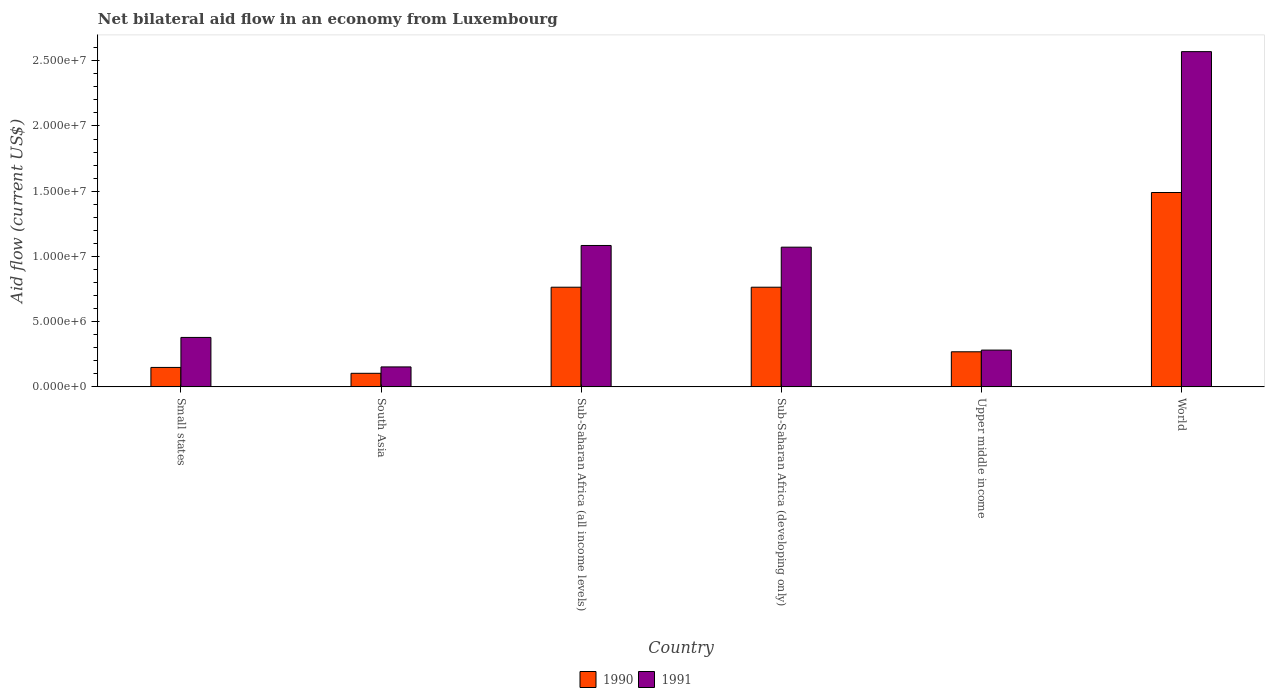Are the number of bars per tick equal to the number of legend labels?
Ensure brevity in your answer.  Yes. How many bars are there on the 3rd tick from the left?
Make the answer very short. 2. What is the label of the 4th group of bars from the left?
Make the answer very short. Sub-Saharan Africa (developing only). What is the net bilateral aid flow in 1991 in Upper middle income?
Give a very brief answer. 2.82e+06. Across all countries, what is the maximum net bilateral aid flow in 1991?
Your answer should be very brief. 2.57e+07. Across all countries, what is the minimum net bilateral aid flow in 1990?
Make the answer very short. 1.04e+06. In which country was the net bilateral aid flow in 1991 minimum?
Ensure brevity in your answer.  South Asia. What is the total net bilateral aid flow in 1990 in the graph?
Provide a short and direct response. 3.54e+07. What is the difference between the net bilateral aid flow in 1991 in Small states and that in World?
Provide a short and direct response. -2.19e+07. What is the difference between the net bilateral aid flow in 1991 in Small states and the net bilateral aid flow in 1990 in World?
Your answer should be compact. -1.11e+07. What is the average net bilateral aid flow in 1990 per country?
Keep it short and to the point. 5.90e+06. What is the difference between the net bilateral aid flow of/in 1991 and net bilateral aid flow of/in 1990 in World?
Your response must be concise. 1.08e+07. In how many countries, is the net bilateral aid flow in 1991 greater than 13000000 US$?
Your answer should be compact. 1. What is the ratio of the net bilateral aid flow in 1991 in Small states to that in World?
Make the answer very short. 0.15. Is the difference between the net bilateral aid flow in 1991 in South Asia and Upper middle income greater than the difference between the net bilateral aid flow in 1990 in South Asia and Upper middle income?
Keep it short and to the point. Yes. What is the difference between the highest and the second highest net bilateral aid flow in 1991?
Give a very brief answer. 1.50e+07. What is the difference between the highest and the lowest net bilateral aid flow in 1990?
Provide a succinct answer. 1.39e+07. What does the 2nd bar from the left in Sub-Saharan Africa (all income levels) represents?
Offer a terse response. 1991. What does the 2nd bar from the right in Sub-Saharan Africa (all income levels) represents?
Keep it short and to the point. 1990. How many bars are there?
Keep it short and to the point. 12. Are all the bars in the graph horizontal?
Offer a terse response. No. What is the difference between two consecutive major ticks on the Y-axis?
Offer a terse response. 5.00e+06. Are the values on the major ticks of Y-axis written in scientific E-notation?
Ensure brevity in your answer.  Yes. Does the graph contain grids?
Your answer should be very brief. No. How are the legend labels stacked?
Your answer should be compact. Horizontal. What is the title of the graph?
Offer a terse response. Net bilateral aid flow in an economy from Luxembourg. What is the label or title of the X-axis?
Give a very brief answer. Country. What is the label or title of the Y-axis?
Offer a terse response. Aid flow (current US$). What is the Aid flow (current US$) in 1990 in Small states?
Keep it short and to the point. 1.49e+06. What is the Aid flow (current US$) in 1991 in Small states?
Offer a very short reply. 3.79e+06. What is the Aid flow (current US$) in 1990 in South Asia?
Make the answer very short. 1.04e+06. What is the Aid flow (current US$) in 1991 in South Asia?
Your answer should be compact. 1.53e+06. What is the Aid flow (current US$) in 1990 in Sub-Saharan Africa (all income levels)?
Offer a terse response. 7.64e+06. What is the Aid flow (current US$) of 1991 in Sub-Saharan Africa (all income levels)?
Ensure brevity in your answer.  1.08e+07. What is the Aid flow (current US$) of 1990 in Sub-Saharan Africa (developing only)?
Make the answer very short. 7.64e+06. What is the Aid flow (current US$) in 1991 in Sub-Saharan Africa (developing only)?
Your answer should be very brief. 1.07e+07. What is the Aid flow (current US$) of 1990 in Upper middle income?
Ensure brevity in your answer.  2.69e+06. What is the Aid flow (current US$) of 1991 in Upper middle income?
Your answer should be compact. 2.82e+06. What is the Aid flow (current US$) of 1990 in World?
Provide a succinct answer. 1.49e+07. What is the Aid flow (current US$) of 1991 in World?
Provide a short and direct response. 2.57e+07. Across all countries, what is the maximum Aid flow (current US$) in 1990?
Your answer should be compact. 1.49e+07. Across all countries, what is the maximum Aid flow (current US$) in 1991?
Offer a very short reply. 2.57e+07. Across all countries, what is the minimum Aid flow (current US$) in 1990?
Your answer should be compact. 1.04e+06. Across all countries, what is the minimum Aid flow (current US$) of 1991?
Provide a succinct answer. 1.53e+06. What is the total Aid flow (current US$) in 1990 in the graph?
Ensure brevity in your answer.  3.54e+07. What is the total Aid flow (current US$) in 1991 in the graph?
Offer a terse response. 5.54e+07. What is the difference between the Aid flow (current US$) in 1991 in Small states and that in South Asia?
Make the answer very short. 2.26e+06. What is the difference between the Aid flow (current US$) in 1990 in Small states and that in Sub-Saharan Africa (all income levels)?
Ensure brevity in your answer.  -6.15e+06. What is the difference between the Aid flow (current US$) in 1991 in Small states and that in Sub-Saharan Africa (all income levels)?
Ensure brevity in your answer.  -7.05e+06. What is the difference between the Aid flow (current US$) of 1990 in Small states and that in Sub-Saharan Africa (developing only)?
Give a very brief answer. -6.15e+06. What is the difference between the Aid flow (current US$) of 1991 in Small states and that in Sub-Saharan Africa (developing only)?
Ensure brevity in your answer.  -6.92e+06. What is the difference between the Aid flow (current US$) of 1990 in Small states and that in Upper middle income?
Offer a very short reply. -1.20e+06. What is the difference between the Aid flow (current US$) in 1991 in Small states and that in Upper middle income?
Provide a short and direct response. 9.70e+05. What is the difference between the Aid flow (current US$) in 1990 in Small states and that in World?
Ensure brevity in your answer.  -1.34e+07. What is the difference between the Aid flow (current US$) of 1991 in Small states and that in World?
Give a very brief answer. -2.19e+07. What is the difference between the Aid flow (current US$) of 1990 in South Asia and that in Sub-Saharan Africa (all income levels)?
Provide a succinct answer. -6.60e+06. What is the difference between the Aid flow (current US$) in 1991 in South Asia and that in Sub-Saharan Africa (all income levels)?
Ensure brevity in your answer.  -9.31e+06. What is the difference between the Aid flow (current US$) in 1990 in South Asia and that in Sub-Saharan Africa (developing only)?
Your response must be concise. -6.60e+06. What is the difference between the Aid flow (current US$) in 1991 in South Asia and that in Sub-Saharan Africa (developing only)?
Make the answer very short. -9.18e+06. What is the difference between the Aid flow (current US$) in 1990 in South Asia and that in Upper middle income?
Make the answer very short. -1.65e+06. What is the difference between the Aid flow (current US$) of 1991 in South Asia and that in Upper middle income?
Offer a terse response. -1.29e+06. What is the difference between the Aid flow (current US$) in 1990 in South Asia and that in World?
Provide a short and direct response. -1.39e+07. What is the difference between the Aid flow (current US$) in 1991 in South Asia and that in World?
Offer a very short reply. -2.42e+07. What is the difference between the Aid flow (current US$) of 1990 in Sub-Saharan Africa (all income levels) and that in Sub-Saharan Africa (developing only)?
Provide a short and direct response. 0. What is the difference between the Aid flow (current US$) of 1990 in Sub-Saharan Africa (all income levels) and that in Upper middle income?
Make the answer very short. 4.95e+06. What is the difference between the Aid flow (current US$) of 1991 in Sub-Saharan Africa (all income levels) and that in Upper middle income?
Offer a very short reply. 8.02e+06. What is the difference between the Aid flow (current US$) of 1990 in Sub-Saharan Africa (all income levels) and that in World?
Your answer should be compact. -7.26e+06. What is the difference between the Aid flow (current US$) in 1991 in Sub-Saharan Africa (all income levels) and that in World?
Offer a very short reply. -1.49e+07. What is the difference between the Aid flow (current US$) in 1990 in Sub-Saharan Africa (developing only) and that in Upper middle income?
Provide a succinct answer. 4.95e+06. What is the difference between the Aid flow (current US$) of 1991 in Sub-Saharan Africa (developing only) and that in Upper middle income?
Provide a succinct answer. 7.89e+06. What is the difference between the Aid flow (current US$) in 1990 in Sub-Saharan Africa (developing only) and that in World?
Your response must be concise. -7.26e+06. What is the difference between the Aid flow (current US$) of 1991 in Sub-Saharan Africa (developing only) and that in World?
Provide a short and direct response. -1.50e+07. What is the difference between the Aid flow (current US$) of 1990 in Upper middle income and that in World?
Offer a very short reply. -1.22e+07. What is the difference between the Aid flow (current US$) in 1991 in Upper middle income and that in World?
Your response must be concise. -2.29e+07. What is the difference between the Aid flow (current US$) in 1990 in Small states and the Aid flow (current US$) in 1991 in South Asia?
Your answer should be compact. -4.00e+04. What is the difference between the Aid flow (current US$) in 1990 in Small states and the Aid flow (current US$) in 1991 in Sub-Saharan Africa (all income levels)?
Give a very brief answer. -9.35e+06. What is the difference between the Aid flow (current US$) in 1990 in Small states and the Aid flow (current US$) in 1991 in Sub-Saharan Africa (developing only)?
Offer a terse response. -9.22e+06. What is the difference between the Aid flow (current US$) of 1990 in Small states and the Aid flow (current US$) of 1991 in Upper middle income?
Make the answer very short. -1.33e+06. What is the difference between the Aid flow (current US$) in 1990 in Small states and the Aid flow (current US$) in 1991 in World?
Give a very brief answer. -2.42e+07. What is the difference between the Aid flow (current US$) in 1990 in South Asia and the Aid flow (current US$) in 1991 in Sub-Saharan Africa (all income levels)?
Your answer should be compact. -9.80e+06. What is the difference between the Aid flow (current US$) in 1990 in South Asia and the Aid flow (current US$) in 1991 in Sub-Saharan Africa (developing only)?
Offer a terse response. -9.67e+06. What is the difference between the Aid flow (current US$) of 1990 in South Asia and the Aid flow (current US$) of 1991 in Upper middle income?
Ensure brevity in your answer.  -1.78e+06. What is the difference between the Aid flow (current US$) of 1990 in South Asia and the Aid flow (current US$) of 1991 in World?
Provide a succinct answer. -2.47e+07. What is the difference between the Aid flow (current US$) of 1990 in Sub-Saharan Africa (all income levels) and the Aid flow (current US$) of 1991 in Sub-Saharan Africa (developing only)?
Make the answer very short. -3.07e+06. What is the difference between the Aid flow (current US$) in 1990 in Sub-Saharan Africa (all income levels) and the Aid flow (current US$) in 1991 in Upper middle income?
Provide a short and direct response. 4.82e+06. What is the difference between the Aid flow (current US$) of 1990 in Sub-Saharan Africa (all income levels) and the Aid flow (current US$) of 1991 in World?
Your answer should be compact. -1.81e+07. What is the difference between the Aid flow (current US$) in 1990 in Sub-Saharan Africa (developing only) and the Aid flow (current US$) in 1991 in Upper middle income?
Provide a short and direct response. 4.82e+06. What is the difference between the Aid flow (current US$) in 1990 in Sub-Saharan Africa (developing only) and the Aid flow (current US$) in 1991 in World?
Provide a succinct answer. -1.81e+07. What is the difference between the Aid flow (current US$) in 1990 in Upper middle income and the Aid flow (current US$) in 1991 in World?
Provide a succinct answer. -2.30e+07. What is the average Aid flow (current US$) in 1990 per country?
Offer a very short reply. 5.90e+06. What is the average Aid flow (current US$) in 1991 per country?
Provide a succinct answer. 9.23e+06. What is the difference between the Aid flow (current US$) in 1990 and Aid flow (current US$) in 1991 in Small states?
Your answer should be compact. -2.30e+06. What is the difference between the Aid flow (current US$) of 1990 and Aid flow (current US$) of 1991 in South Asia?
Provide a succinct answer. -4.90e+05. What is the difference between the Aid flow (current US$) in 1990 and Aid flow (current US$) in 1991 in Sub-Saharan Africa (all income levels)?
Provide a short and direct response. -3.20e+06. What is the difference between the Aid flow (current US$) of 1990 and Aid flow (current US$) of 1991 in Sub-Saharan Africa (developing only)?
Make the answer very short. -3.07e+06. What is the difference between the Aid flow (current US$) in 1990 and Aid flow (current US$) in 1991 in World?
Provide a short and direct response. -1.08e+07. What is the ratio of the Aid flow (current US$) in 1990 in Small states to that in South Asia?
Your response must be concise. 1.43. What is the ratio of the Aid flow (current US$) of 1991 in Small states to that in South Asia?
Offer a very short reply. 2.48. What is the ratio of the Aid flow (current US$) of 1990 in Small states to that in Sub-Saharan Africa (all income levels)?
Ensure brevity in your answer.  0.2. What is the ratio of the Aid flow (current US$) in 1991 in Small states to that in Sub-Saharan Africa (all income levels)?
Your answer should be compact. 0.35. What is the ratio of the Aid flow (current US$) of 1990 in Small states to that in Sub-Saharan Africa (developing only)?
Offer a very short reply. 0.2. What is the ratio of the Aid flow (current US$) of 1991 in Small states to that in Sub-Saharan Africa (developing only)?
Ensure brevity in your answer.  0.35. What is the ratio of the Aid flow (current US$) of 1990 in Small states to that in Upper middle income?
Your response must be concise. 0.55. What is the ratio of the Aid flow (current US$) in 1991 in Small states to that in Upper middle income?
Your answer should be compact. 1.34. What is the ratio of the Aid flow (current US$) in 1991 in Small states to that in World?
Your answer should be very brief. 0.15. What is the ratio of the Aid flow (current US$) in 1990 in South Asia to that in Sub-Saharan Africa (all income levels)?
Provide a succinct answer. 0.14. What is the ratio of the Aid flow (current US$) of 1991 in South Asia to that in Sub-Saharan Africa (all income levels)?
Provide a succinct answer. 0.14. What is the ratio of the Aid flow (current US$) in 1990 in South Asia to that in Sub-Saharan Africa (developing only)?
Give a very brief answer. 0.14. What is the ratio of the Aid flow (current US$) of 1991 in South Asia to that in Sub-Saharan Africa (developing only)?
Make the answer very short. 0.14. What is the ratio of the Aid flow (current US$) of 1990 in South Asia to that in Upper middle income?
Make the answer very short. 0.39. What is the ratio of the Aid flow (current US$) of 1991 in South Asia to that in Upper middle income?
Make the answer very short. 0.54. What is the ratio of the Aid flow (current US$) of 1990 in South Asia to that in World?
Your response must be concise. 0.07. What is the ratio of the Aid flow (current US$) of 1991 in South Asia to that in World?
Your answer should be very brief. 0.06. What is the ratio of the Aid flow (current US$) of 1990 in Sub-Saharan Africa (all income levels) to that in Sub-Saharan Africa (developing only)?
Your response must be concise. 1. What is the ratio of the Aid flow (current US$) in 1991 in Sub-Saharan Africa (all income levels) to that in Sub-Saharan Africa (developing only)?
Make the answer very short. 1.01. What is the ratio of the Aid flow (current US$) in 1990 in Sub-Saharan Africa (all income levels) to that in Upper middle income?
Your answer should be compact. 2.84. What is the ratio of the Aid flow (current US$) in 1991 in Sub-Saharan Africa (all income levels) to that in Upper middle income?
Provide a succinct answer. 3.84. What is the ratio of the Aid flow (current US$) in 1990 in Sub-Saharan Africa (all income levels) to that in World?
Keep it short and to the point. 0.51. What is the ratio of the Aid flow (current US$) of 1991 in Sub-Saharan Africa (all income levels) to that in World?
Ensure brevity in your answer.  0.42. What is the ratio of the Aid flow (current US$) in 1990 in Sub-Saharan Africa (developing only) to that in Upper middle income?
Offer a terse response. 2.84. What is the ratio of the Aid flow (current US$) of 1991 in Sub-Saharan Africa (developing only) to that in Upper middle income?
Your answer should be very brief. 3.8. What is the ratio of the Aid flow (current US$) in 1990 in Sub-Saharan Africa (developing only) to that in World?
Provide a succinct answer. 0.51. What is the ratio of the Aid flow (current US$) in 1991 in Sub-Saharan Africa (developing only) to that in World?
Ensure brevity in your answer.  0.42. What is the ratio of the Aid flow (current US$) of 1990 in Upper middle income to that in World?
Keep it short and to the point. 0.18. What is the ratio of the Aid flow (current US$) in 1991 in Upper middle income to that in World?
Provide a short and direct response. 0.11. What is the difference between the highest and the second highest Aid flow (current US$) of 1990?
Make the answer very short. 7.26e+06. What is the difference between the highest and the second highest Aid flow (current US$) of 1991?
Offer a terse response. 1.49e+07. What is the difference between the highest and the lowest Aid flow (current US$) of 1990?
Give a very brief answer. 1.39e+07. What is the difference between the highest and the lowest Aid flow (current US$) in 1991?
Offer a very short reply. 2.42e+07. 